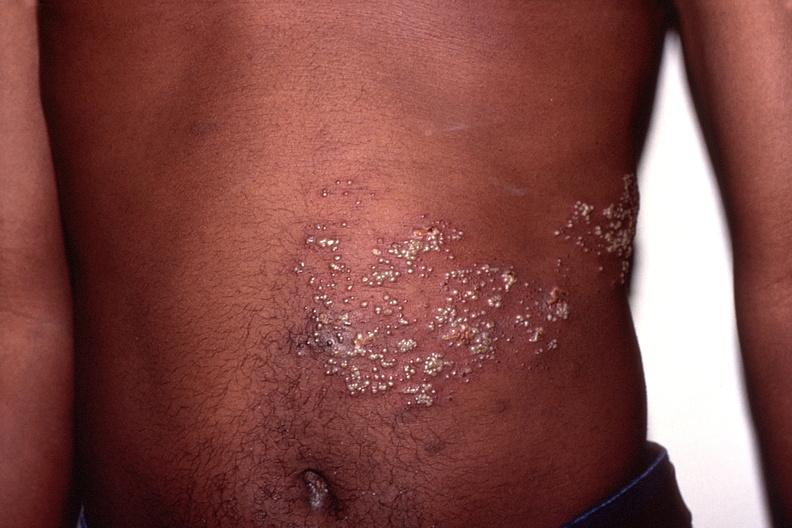does this image show herpes zoster?
Answer the question using a single word or phrase. Yes 